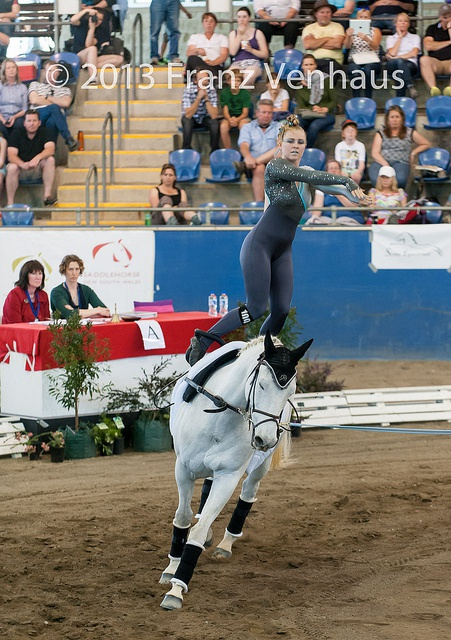Describe the objects in this image and their specific colors. I can see people in blue, black, gray, tan, and darkgray tones, horse in blue, lightgray, darkgray, black, and gray tones, people in blue, black, navy, gray, and darkblue tones, potted plant in blue, black, darkgreen, lightgray, and brown tones, and potted plant in blue, black, lightgray, gray, and darkgray tones in this image. 